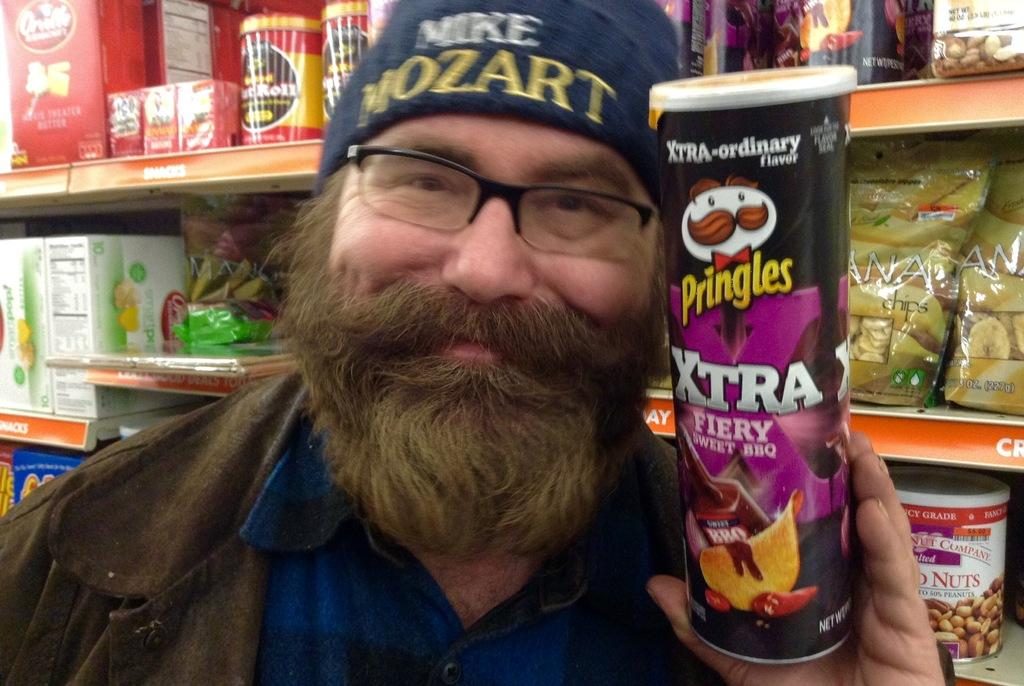What is the main subject of the image? There is a person standing in the middle of the image. What is the person holding in the image? The person is holding a bottle. What can be seen in the background of the image? There is a shelf in the background of the image. What is on the shelf in the image? There are objects on the shelf. Can you see a tin floating down the river in the image? There is no tin or river present in the image. What type of pickle is the person holding in the image? The person is holding a bottle, not a pickle, in the image. 